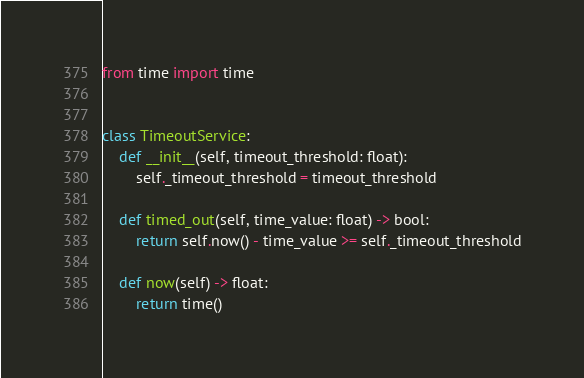<code> <loc_0><loc_0><loc_500><loc_500><_Python_>from time import time


class TimeoutService:
    def __init__(self, timeout_threshold: float):
        self._timeout_threshold = timeout_threshold

    def timed_out(self, time_value: float) -> bool:
        return self.now() - time_value >= self._timeout_threshold

    def now(self) -> float:
        return time()
</code> 